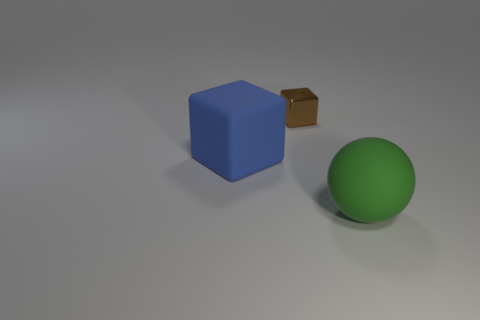What number of rubber objects are either brown cubes or red cylinders?
Your response must be concise. 0. What is the green ball made of?
Provide a succinct answer. Rubber. What material is the large object to the left of the big rubber object that is on the right side of the large matte thing that is to the left of the tiny brown metal cube?
Make the answer very short. Rubber. What shape is the blue matte thing that is the same size as the green thing?
Give a very brief answer. Cube. What number of things are small blue rubber cylinders or tiny shiny things on the left side of the big green matte thing?
Provide a succinct answer. 1. Is the large thing in front of the blue block made of the same material as the large thing that is on the left side of the brown thing?
Provide a succinct answer. Yes. What number of brown things are either large shiny cylinders or metal things?
Keep it short and to the point. 1. What size is the green matte ball?
Offer a very short reply. Large. Is the number of small objects that are in front of the rubber sphere greater than the number of blue blocks?
Give a very brief answer. No. There is a tiny brown cube; how many big rubber objects are to the right of it?
Make the answer very short. 1. 